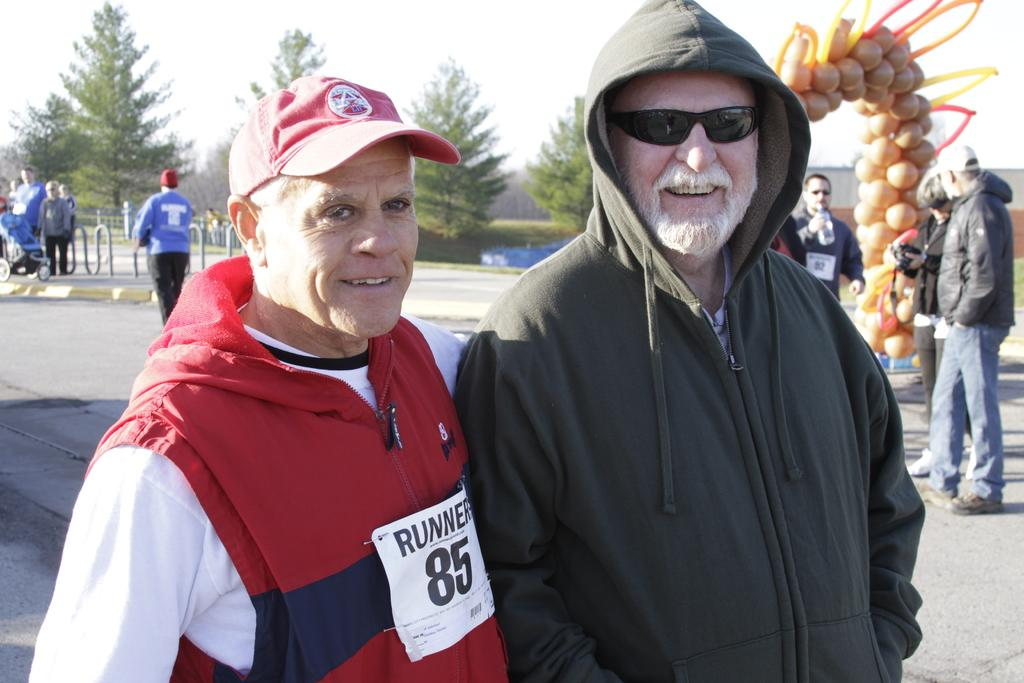How many men are present in the image? There are two men in the image. What is the facial expression of the men? The men are smiling. What can be seen in the background of the image? There are people, a fence, trees, the sky, and some objects in the background of the image. What type of soap is being used by the men in the image? There is no soap present in the image; the men are simply smiling. How does the alley look in the image? There is no alley present in the image; it features a fence, trees, and other objects in the background. 